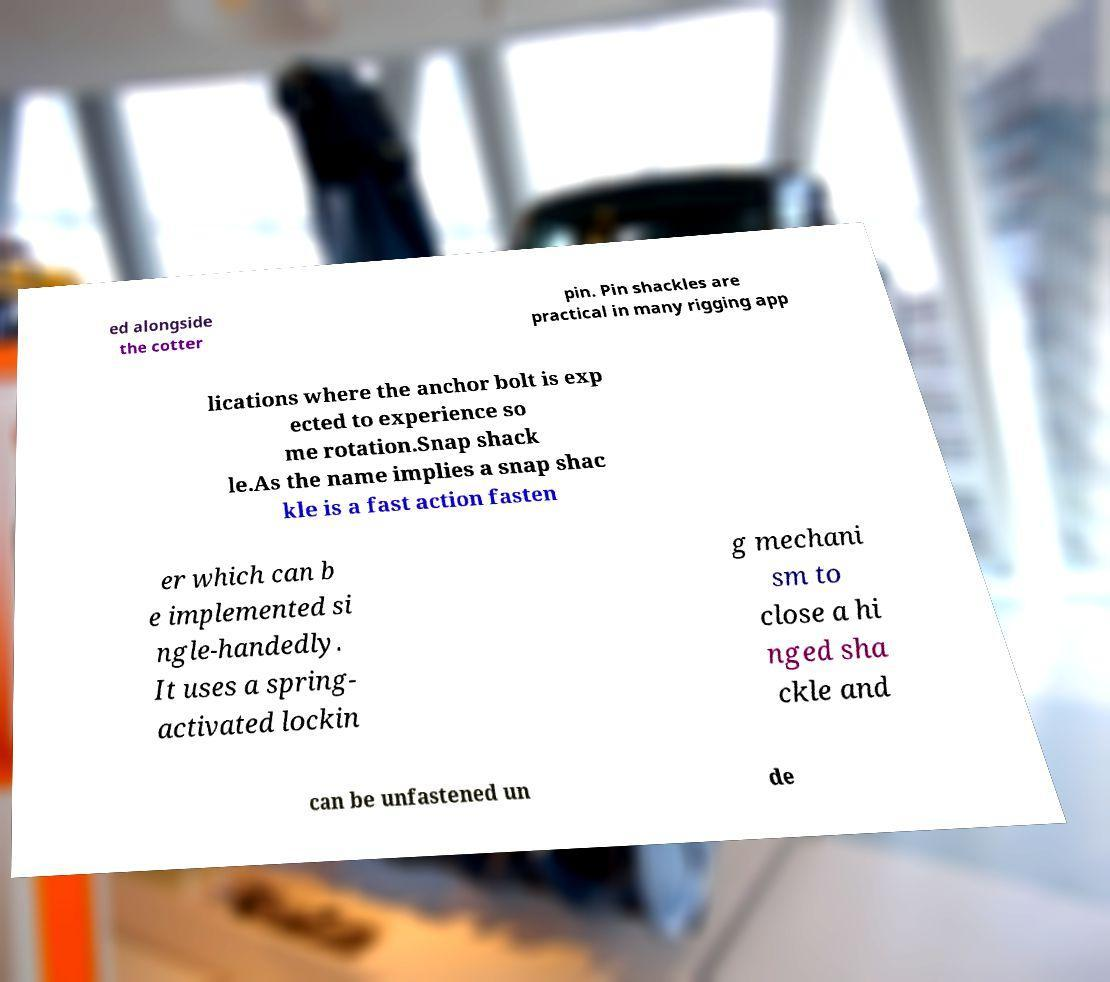For documentation purposes, I need the text within this image transcribed. Could you provide that? ed alongside the cotter pin. Pin shackles are practical in many rigging app lications where the anchor bolt is exp ected to experience so me rotation.Snap shack le.As the name implies a snap shac kle is a fast action fasten er which can b e implemented si ngle-handedly. It uses a spring- activated lockin g mechani sm to close a hi nged sha ckle and can be unfastened un de 